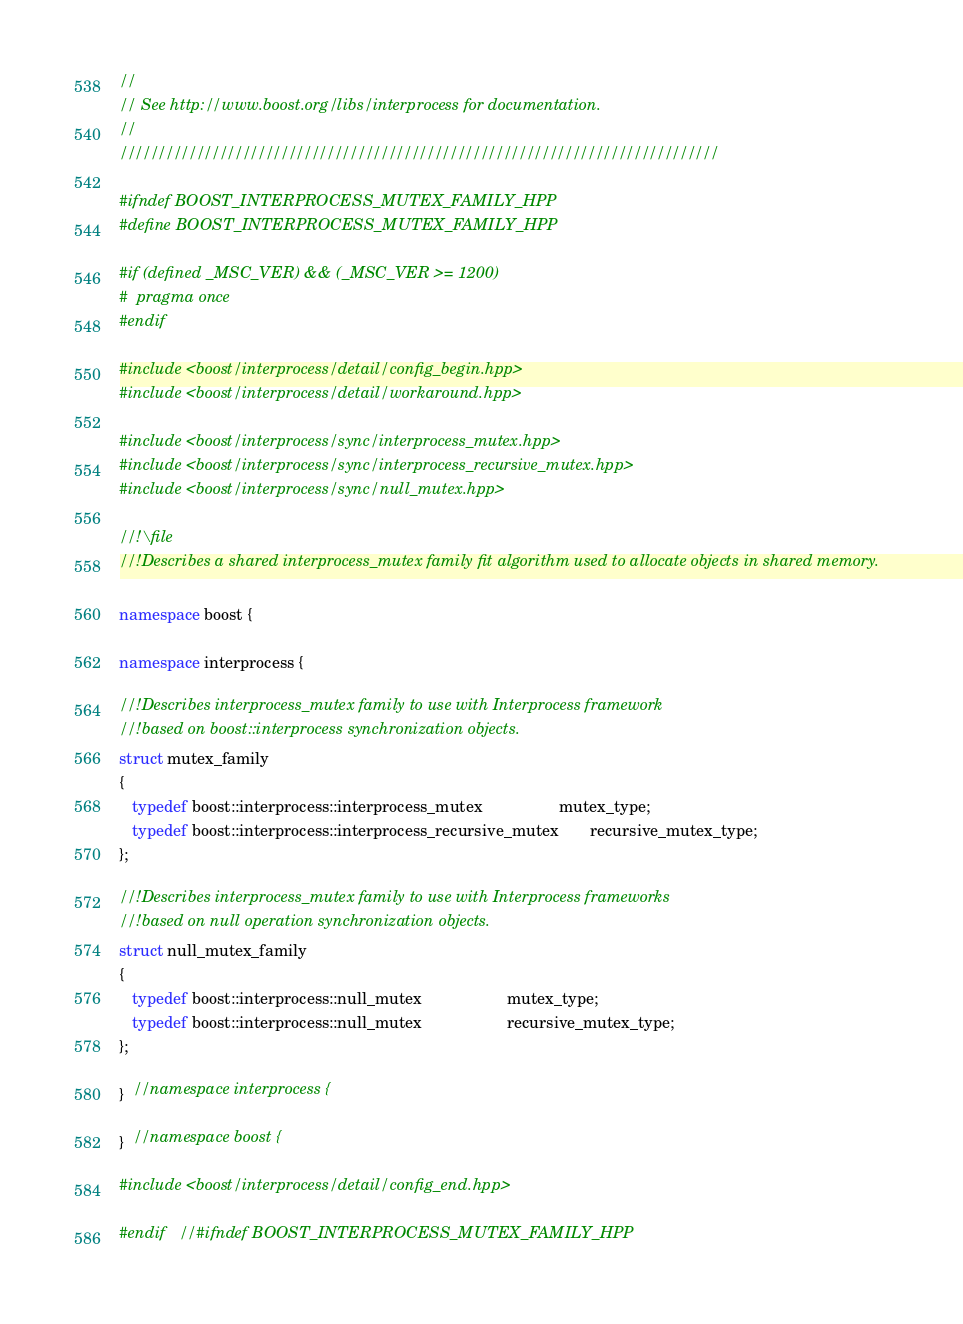<code> <loc_0><loc_0><loc_500><loc_500><_C++_>//
// See http://www.boost.org/libs/interprocess for documentation.
//
//////////////////////////////////////////////////////////////////////////////

#ifndef BOOST_INTERPROCESS_MUTEX_FAMILY_HPP
#define BOOST_INTERPROCESS_MUTEX_FAMILY_HPP

#if (defined _MSC_VER) && (_MSC_VER >= 1200)
#  pragma once
#endif

#include <boost/interprocess/detail/config_begin.hpp>
#include <boost/interprocess/detail/workaround.hpp>

#include <boost/interprocess/sync/interprocess_mutex.hpp>
#include <boost/interprocess/sync/interprocess_recursive_mutex.hpp>
#include <boost/interprocess/sync/null_mutex.hpp>

//!\file
//!Describes a shared interprocess_mutex family fit algorithm used to allocate objects in shared memory.

namespace boost {

namespace interprocess {

//!Describes interprocess_mutex family to use with Interprocess framework
//!based on boost::interprocess synchronization objects.
struct mutex_family
{
   typedef boost::interprocess::interprocess_mutex                 mutex_type;
   typedef boost::interprocess::interprocess_recursive_mutex       recursive_mutex_type;
};

//!Describes interprocess_mutex family to use with Interprocess frameworks
//!based on null operation synchronization objects.
struct null_mutex_family
{
   typedef boost::interprocess::null_mutex                   mutex_type;
   typedef boost::interprocess::null_mutex                   recursive_mutex_type;
};

}  //namespace interprocess {

}  //namespace boost {

#include <boost/interprocess/detail/config_end.hpp>

#endif   //#ifndef BOOST_INTERPROCESS_MUTEX_FAMILY_HPP


</code> 